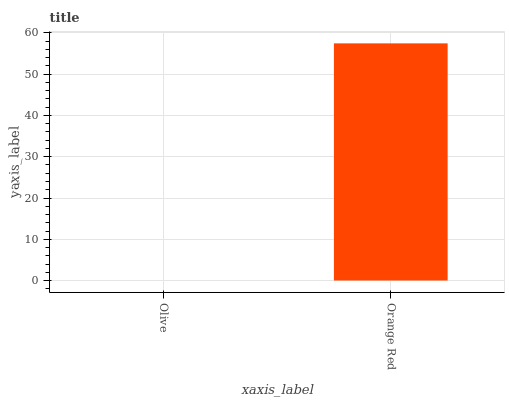Is Olive the minimum?
Answer yes or no. Yes. Is Orange Red the maximum?
Answer yes or no. Yes. Is Orange Red the minimum?
Answer yes or no. No. Is Orange Red greater than Olive?
Answer yes or no. Yes. Is Olive less than Orange Red?
Answer yes or no. Yes. Is Olive greater than Orange Red?
Answer yes or no. No. Is Orange Red less than Olive?
Answer yes or no. No. Is Orange Red the high median?
Answer yes or no. Yes. Is Olive the low median?
Answer yes or no. Yes. Is Olive the high median?
Answer yes or no. No. Is Orange Red the low median?
Answer yes or no. No. 